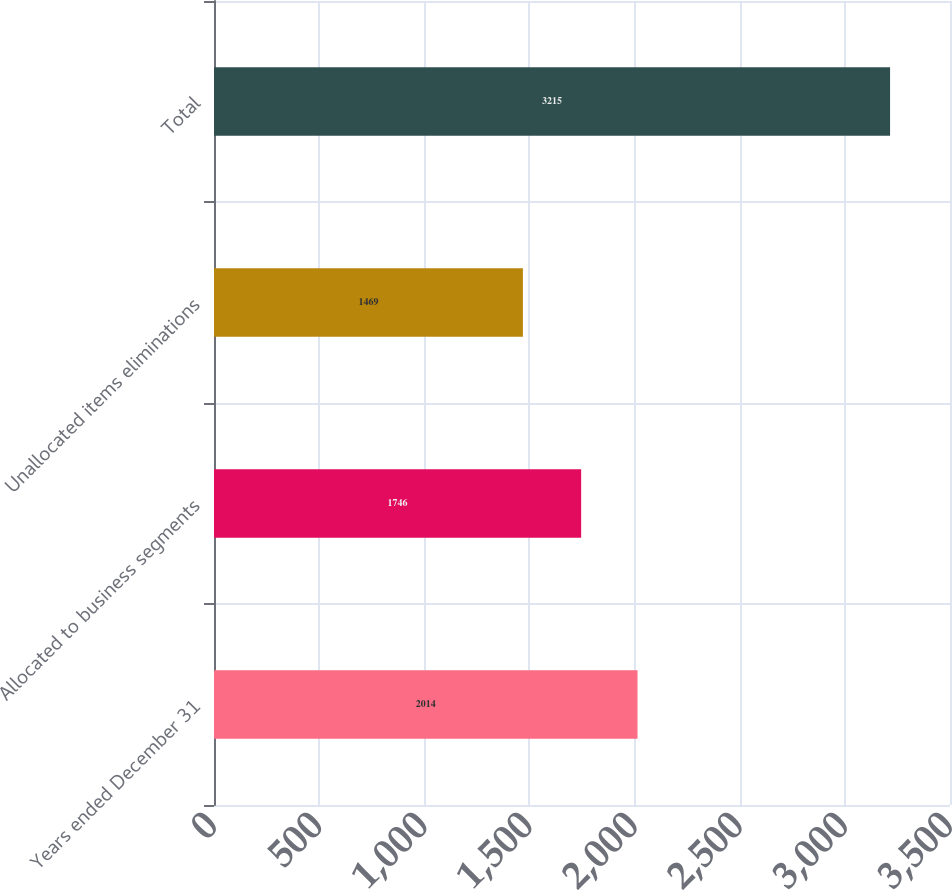Convert chart to OTSL. <chart><loc_0><loc_0><loc_500><loc_500><bar_chart><fcel>Years ended December 31<fcel>Allocated to business segments<fcel>Unallocated items eliminations<fcel>Total<nl><fcel>2014<fcel>1746<fcel>1469<fcel>3215<nl></chart> 